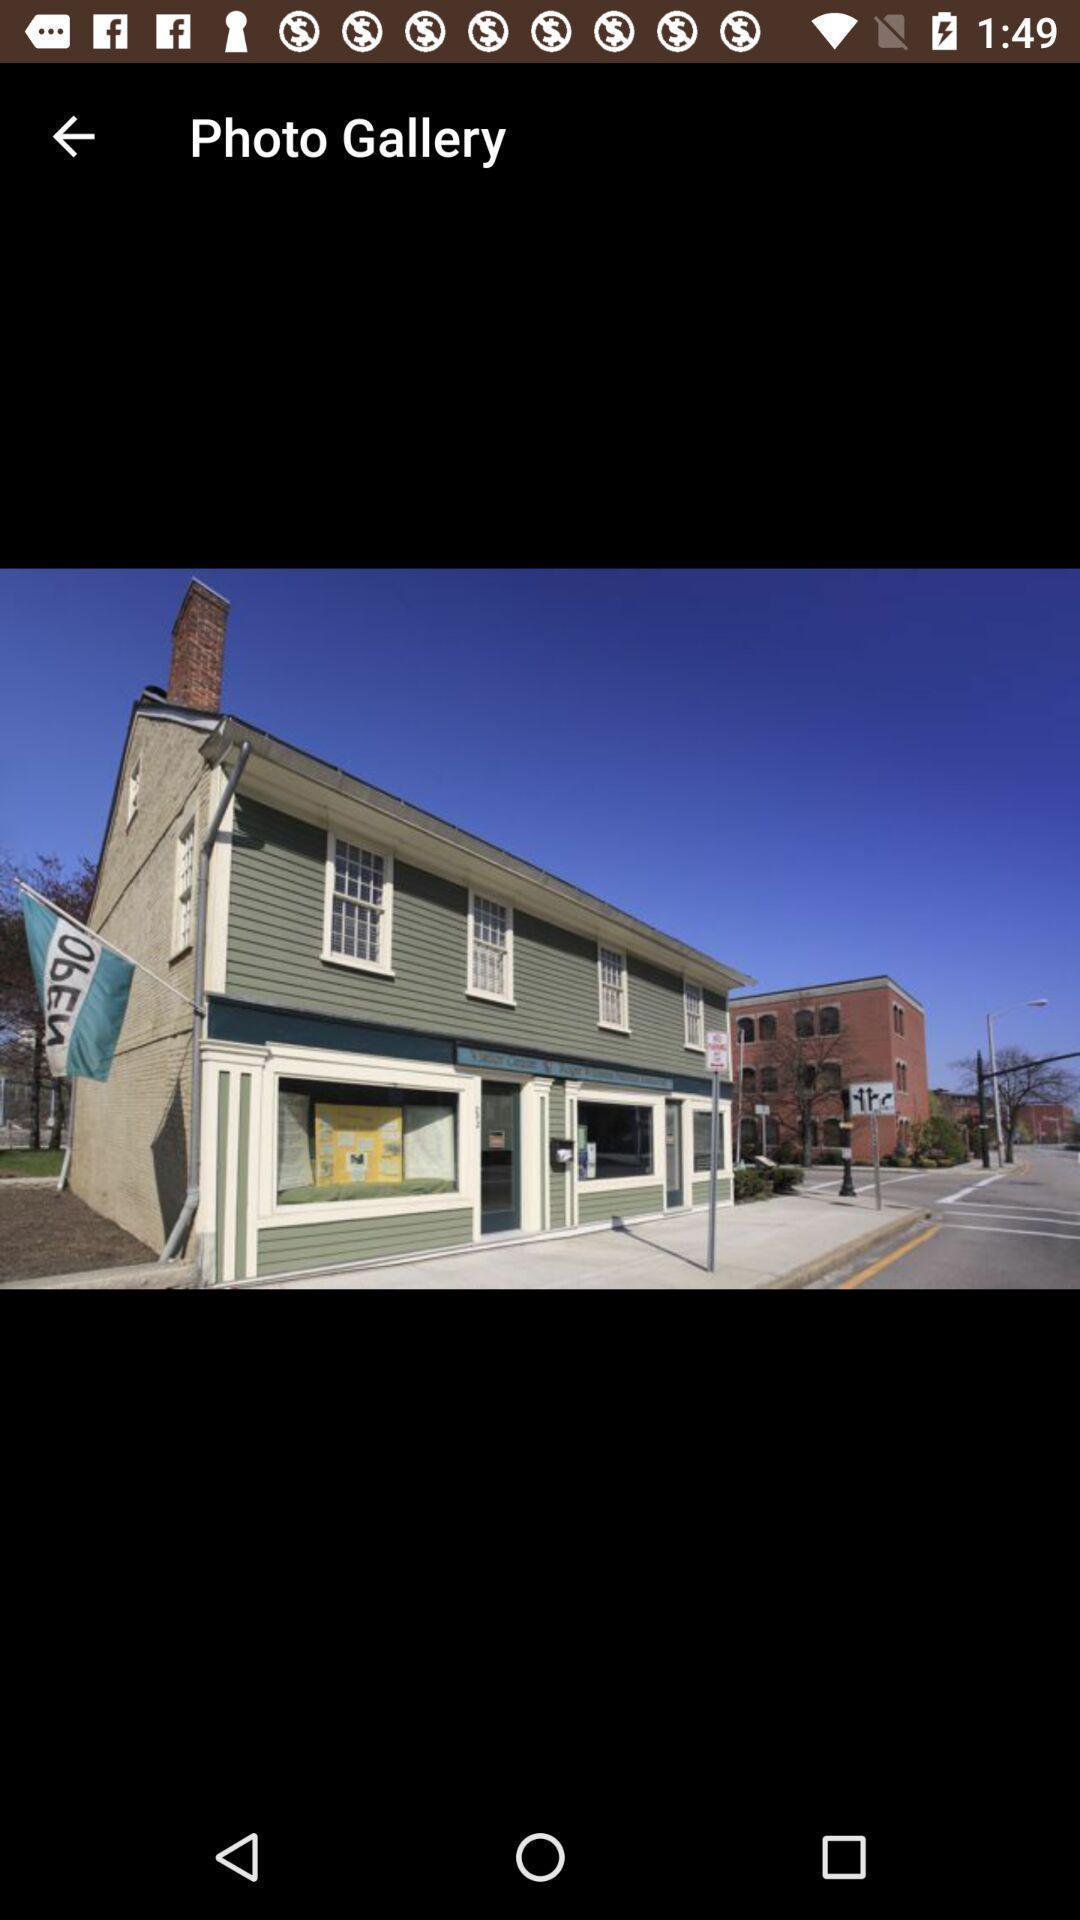What details can you identify in this image? Screen displaying an image. 